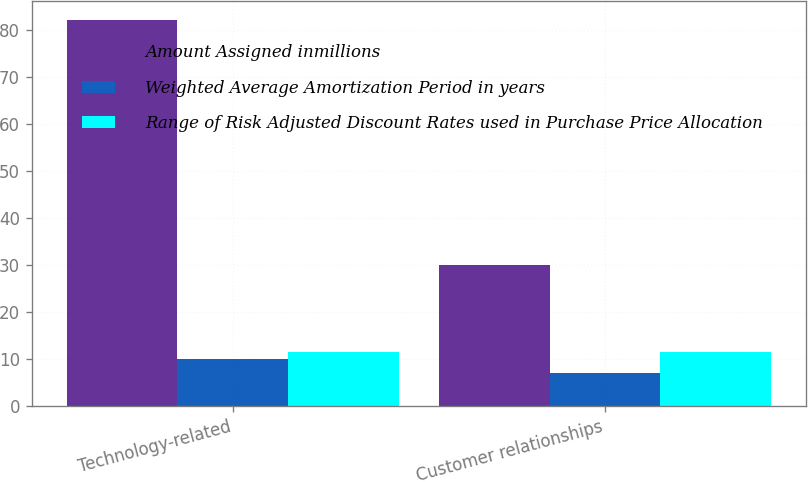Convert chart. <chart><loc_0><loc_0><loc_500><loc_500><stacked_bar_chart><ecel><fcel>Technology-related<fcel>Customer relationships<nl><fcel>Amount Assigned inmillions<fcel>82<fcel>30<nl><fcel>Weighted Average Amortization Period in years<fcel>10<fcel>7<nl><fcel>Range of Risk Adjusted Discount Rates used in Purchase Price Allocation<fcel>11.5<fcel>11.5<nl></chart> 